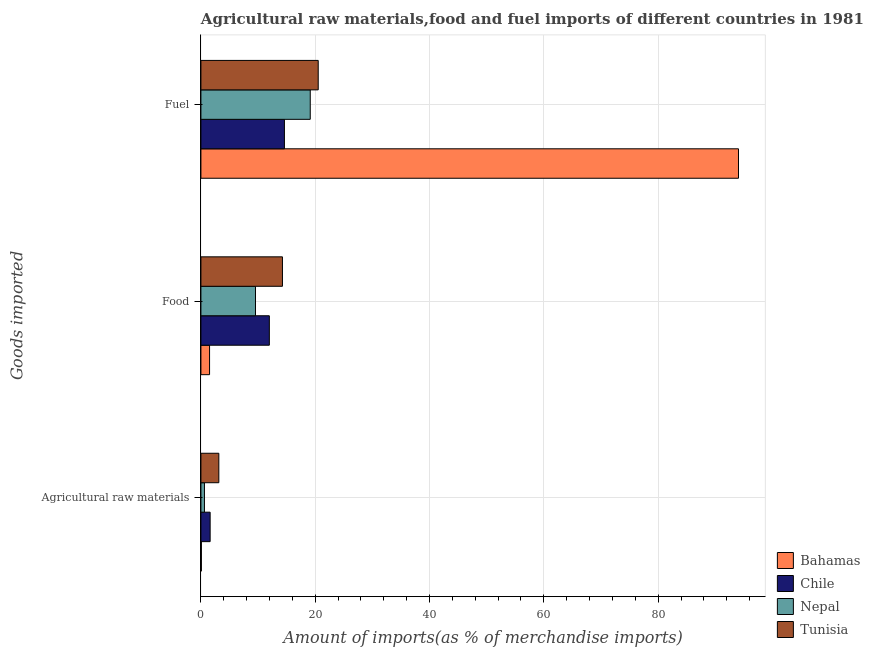How many bars are there on the 1st tick from the bottom?
Your answer should be compact. 4. What is the label of the 1st group of bars from the top?
Keep it short and to the point. Fuel. What is the percentage of fuel imports in Chile?
Your response must be concise. 14.61. Across all countries, what is the maximum percentage of food imports?
Your answer should be very brief. 14.27. Across all countries, what is the minimum percentage of fuel imports?
Ensure brevity in your answer.  14.61. In which country was the percentage of fuel imports maximum?
Make the answer very short. Bahamas. What is the total percentage of raw materials imports in the graph?
Your answer should be very brief. 5.45. What is the difference between the percentage of food imports in Tunisia and that in Nepal?
Give a very brief answer. 4.72. What is the difference between the percentage of raw materials imports in Tunisia and the percentage of fuel imports in Nepal?
Offer a very short reply. -15.99. What is the average percentage of food imports per country?
Offer a terse response. 9.33. What is the difference between the percentage of food imports and percentage of fuel imports in Chile?
Offer a terse response. -2.64. What is the ratio of the percentage of food imports in Chile to that in Bahamas?
Offer a terse response. 7.91. Is the percentage of fuel imports in Bahamas less than that in Nepal?
Offer a terse response. No. Is the difference between the percentage of raw materials imports in Tunisia and Chile greater than the difference between the percentage of fuel imports in Tunisia and Chile?
Provide a succinct answer. No. What is the difference between the highest and the second highest percentage of raw materials imports?
Ensure brevity in your answer.  1.52. What is the difference between the highest and the lowest percentage of fuel imports?
Offer a very short reply. 79.45. In how many countries, is the percentage of food imports greater than the average percentage of food imports taken over all countries?
Your answer should be very brief. 3. What does the 3rd bar from the top in Fuel represents?
Provide a succinct answer. Chile. What does the 2nd bar from the bottom in Food represents?
Keep it short and to the point. Chile. How many bars are there?
Provide a short and direct response. 12. Are all the bars in the graph horizontal?
Ensure brevity in your answer.  Yes. How many countries are there in the graph?
Give a very brief answer. 4. Are the values on the major ticks of X-axis written in scientific E-notation?
Ensure brevity in your answer.  No. Does the graph contain any zero values?
Make the answer very short. No. How many legend labels are there?
Your response must be concise. 4. What is the title of the graph?
Your answer should be compact. Agricultural raw materials,food and fuel imports of different countries in 1981. What is the label or title of the X-axis?
Offer a very short reply. Amount of imports(as % of merchandise imports). What is the label or title of the Y-axis?
Your answer should be very brief. Goods imported. What is the Amount of imports(as % of merchandise imports) of Bahamas in Agricultural raw materials?
Provide a short and direct response. 0.08. What is the Amount of imports(as % of merchandise imports) of Chile in Agricultural raw materials?
Give a very brief answer. 1.61. What is the Amount of imports(as % of merchandise imports) of Nepal in Agricultural raw materials?
Your response must be concise. 0.62. What is the Amount of imports(as % of merchandise imports) of Tunisia in Agricultural raw materials?
Offer a very short reply. 3.13. What is the Amount of imports(as % of merchandise imports) of Bahamas in Food?
Provide a short and direct response. 1.51. What is the Amount of imports(as % of merchandise imports) in Chile in Food?
Keep it short and to the point. 11.97. What is the Amount of imports(as % of merchandise imports) in Nepal in Food?
Your answer should be very brief. 9.55. What is the Amount of imports(as % of merchandise imports) in Tunisia in Food?
Ensure brevity in your answer.  14.27. What is the Amount of imports(as % of merchandise imports) of Bahamas in Fuel?
Provide a short and direct response. 94.06. What is the Amount of imports(as % of merchandise imports) in Chile in Fuel?
Offer a terse response. 14.61. What is the Amount of imports(as % of merchandise imports) of Nepal in Fuel?
Offer a very short reply. 19.13. What is the Amount of imports(as % of merchandise imports) in Tunisia in Fuel?
Give a very brief answer. 20.52. Across all Goods imported, what is the maximum Amount of imports(as % of merchandise imports) of Bahamas?
Provide a short and direct response. 94.06. Across all Goods imported, what is the maximum Amount of imports(as % of merchandise imports) in Chile?
Offer a very short reply. 14.61. Across all Goods imported, what is the maximum Amount of imports(as % of merchandise imports) of Nepal?
Make the answer very short. 19.13. Across all Goods imported, what is the maximum Amount of imports(as % of merchandise imports) in Tunisia?
Make the answer very short. 20.52. Across all Goods imported, what is the minimum Amount of imports(as % of merchandise imports) in Bahamas?
Make the answer very short. 0.08. Across all Goods imported, what is the minimum Amount of imports(as % of merchandise imports) in Chile?
Provide a short and direct response. 1.61. Across all Goods imported, what is the minimum Amount of imports(as % of merchandise imports) in Nepal?
Give a very brief answer. 0.62. Across all Goods imported, what is the minimum Amount of imports(as % of merchandise imports) of Tunisia?
Offer a terse response. 3.13. What is the total Amount of imports(as % of merchandise imports) of Bahamas in the graph?
Provide a succinct answer. 95.65. What is the total Amount of imports(as % of merchandise imports) of Chile in the graph?
Your answer should be compact. 28.2. What is the total Amount of imports(as % of merchandise imports) of Nepal in the graph?
Make the answer very short. 29.29. What is the total Amount of imports(as % of merchandise imports) in Tunisia in the graph?
Your answer should be compact. 37.93. What is the difference between the Amount of imports(as % of merchandise imports) of Bahamas in Agricultural raw materials and that in Food?
Keep it short and to the point. -1.43. What is the difference between the Amount of imports(as % of merchandise imports) in Chile in Agricultural raw materials and that in Food?
Keep it short and to the point. -10.36. What is the difference between the Amount of imports(as % of merchandise imports) in Nepal in Agricultural raw materials and that in Food?
Provide a short and direct response. -8.93. What is the difference between the Amount of imports(as % of merchandise imports) of Tunisia in Agricultural raw materials and that in Food?
Offer a terse response. -11.13. What is the difference between the Amount of imports(as % of merchandise imports) of Bahamas in Agricultural raw materials and that in Fuel?
Make the answer very short. -93.98. What is the difference between the Amount of imports(as % of merchandise imports) in Chile in Agricultural raw materials and that in Fuel?
Your response must be concise. -13. What is the difference between the Amount of imports(as % of merchandise imports) of Nepal in Agricultural raw materials and that in Fuel?
Your answer should be very brief. -18.51. What is the difference between the Amount of imports(as % of merchandise imports) of Tunisia in Agricultural raw materials and that in Fuel?
Offer a terse response. -17.39. What is the difference between the Amount of imports(as % of merchandise imports) in Bahamas in Food and that in Fuel?
Your answer should be very brief. -92.54. What is the difference between the Amount of imports(as % of merchandise imports) of Chile in Food and that in Fuel?
Your response must be concise. -2.64. What is the difference between the Amount of imports(as % of merchandise imports) of Nepal in Food and that in Fuel?
Offer a terse response. -9.58. What is the difference between the Amount of imports(as % of merchandise imports) in Tunisia in Food and that in Fuel?
Provide a short and direct response. -6.26. What is the difference between the Amount of imports(as % of merchandise imports) of Bahamas in Agricultural raw materials and the Amount of imports(as % of merchandise imports) of Chile in Food?
Provide a succinct answer. -11.89. What is the difference between the Amount of imports(as % of merchandise imports) of Bahamas in Agricultural raw materials and the Amount of imports(as % of merchandise imports) of Nepal in Food?
Keep it short and to the point. -9.47. What is the difference between the Amount of imports(as % of merchandise imports) of Bahamas in Agricultural raw materials and the Amount of imports(as % of merchandise imports) of Tunisia in Food?
Your response must be concise. -14.19. What is the difference between the Amount of imports(as % of merchandise imports) of Chile in Agricultural raw materials and the Amount of imports(as % of merchandise imports) of Nepal in Food?
Your answer should be compact. -7.93. What is the difference between the Amount of imports(as % of merchandise imports) of Chile in Agricultural raw materials and the Amount of imports(as % of merchandise imports) of Tunisia in Food?
Make the answer very short. -12.65. What is the difference between the Amount of imports(as % of merchandise imports) of Nepal in Agricultural raw materials and the Amount of imports(as % of merchandise imports) of Tunisia in Food?
Keep it short and to the point. -13.65. What is the difference between the Amount of imports(as % of merchandise imports) in Bahamas in Agricultural raw materials and the Amount of imports(as % of merchandise imports) in Chile in Fuel?
Your answer should be very brief. -14.53. What is the difference between the Amount of imports(as % of merchandise imports) of Bahamas in Agricultural raw materials and the Amount of imports(as % of merchandise imports) of Nepal in Fuel?
Give a very brief answer. -19.05. What is the difference between the Amount of imports(as % of merchandise imports) of Bahamas in Agricultural raw materials and the Amount of imports(as % of merchandise imports) of Tunisia in Fuel?
Offer a very short reply. -20.44. What is the difference between the Amount of imports(as % of merchandise imports) in Chile in Agricultural raw materials and the Amount of imports(as % of merchandise imports) in Nepal in Fuel?
Provide a short and direct response. -17.52. What is the difference between the Amount of imports(as % of merchandise imports) of Chile in Agricultural raw materials and the Amount of imports(as % of merchandise imports) of Tunisia in Fuel?
Provide a succinct answer. -18.91. What is the difference between the Amount of imports(as % of merchandise imports) in Nepal in Agricultural raw materials and the Amount of imports(as % of merchandise imports) in Tunisia in Fuel?
Make the answer very short. -19.91. What is the difference between the Amount of imports(as % of merchandise imports) in Bahamas in Food and the Amount of imports(as % of merchandise imports) in Chile in Fuel?
Offer a terse response. -13.1. What is the difference between the Amount of imports(as % of merchandise imports) in Bahamas in Food and the Amount of imports(as % of merchandise imports) in Nepal in Fuel?
Ensure brevity in your answer.  -17.62. What is the difference between the Amount of imports(as % of merchandise imports) in Bahamas in Food and the Amount of imports(as % of merchandise imports) in Tunisia in Fuel?
Your answer should be very brief. -19.01. What is the difference between the Amount of imports(as % of merchandise imports) of Chile in Food and the Amount of imports(as % of merchandise imports) of Nepal in Fuel?
Offer a terse response. -7.16. What is the difference between the Amount of imports(as % of merchandise imports) of Chile in Food and the Amount of imports(as % of merchandise imports) of Tunisia in Fuel?
Provide a short and direct response. -8.55. What is the difference between the Amount of imports(as % of merchandise imports) in Nepal in Food and the Amount of imports(as % of merchandise imports) in Tunisia in Fuel?
Make the answer very short. -10.98. What is the average Amount of imports(as % of merchandise imports) of Bahamas per Goods imported?
Provide a short and direct response. 31.88. What is the average Amount of imports(as % of merchandise imports) in Chile per Goods imported?
Make the answer very short. 9.4. What is the average Amount of imports(as % of merchandise imports) in Nepal per Goods imported?
Your answer should be compact. 9.76. What is the average Amount of imports(as % of merchandise imports) in Tunisia per Goods imported?
Provide a succinct answer. 12.64. What is the difference between the Amount of imports(as % of merchandise imports) of Bahamas and Amount of imports(as % of merchandise imports) of Chile in Agricultural raw materials?
Keep it short and to the point. -1.53. What is the difference between the Amount of imports(as % of merchandise imports) of Bahamas and Amount of imports(as % of merchandise imports) of Nepal in Agricultural raw materials?
Ensure brevity in your answer.  -0.54. What is the difference between the Amount of imports(as % of merchandise imports) of Bahamas and Amount of imports(as % of merchandise imports) of Tunisia in Agricultural raw materials?
Your answer should be compact. -3.05. What is the difference between the Amount of imports(as % of merchandise imports) of Chile and Amount of imports(as % of merchandise imports) of Nepal in Agricultural raw materials?
Provide a short and direct response. 1. What is the difference between the Amount of imports(as % of merchandise imports) of Chile and Amount of imports(as % of merchandise imports) of Tunisia in Agricultural raw materials?
Ensure brevity in your answer.  -1.52. What is the difference between the Amount of imports(as % of merchandise imports) in Nepal and Amount of imports(as % of merchandise imports) in Tunisia in Agricultural raw materials?
Give a very brief answer. -2.52. What is the difference between the Amount of imports(as % of merchandise imports) in Bahamas and Amount of imports(as % of merchandise imports) in Chile in Food?
Your answer should be compact. -10.46. What is the difference between the Amount of imports(as % of merchandise imports) of Bahamas and Amount of imports(as % of merchandise imports) of Nepal in Food?
Offer a terse response. -8.03. What is the difference between the Amount of imports(as % of merchandise imports) of Bahamas and Amount of imports(as % of merchandise imports) of Tunisia in Food?
Offer a very short reply. -12.75. What is the difference between the Amount of imports(as % of merchandise imports) of Chile and Amount of imports(as % of merchandise imports) of Nepal in Food?
Your answer should be compact. 2.43. What is the difference between the Amount of imports(as % of merchandise imports) in Chile and Amount of imports(as % of merchandise imports) in Tunisia in Food?
Your response must be concise. -2.29. What is the difference between the Amount of imports(as % of merchandise imports) in Nepal and Amount of imports(as % of merchandise imports) in Tunisia in Food?
Ensure brevity in your answer.  -4.72. What is the difference between the Amount of imports(as % of merchandise imports) in Bahamas and Amount of imports(as % of merchandise imports) in Chile in Fuel?
Give a very brief answer. 79.45. What is the difference between the Amount of imports(as % of merchandise imports) in Bahamas and Amount of imports(as % of merchandise imports) in Nepal in Fuel?
Make the answer very short. 74.93. What is the difference between the Amount of imports(as % of merchandise imports) of Bahamas and Amount of imports(as % of merchandise imports) of Tunisia in Fuel?
Provide a short and direct response. 73.53. What is the difference between the Amount of imports(as % of merchandise imports) of Chile and Amount of imports(as % of merchandise imports) of Nepal in Fuel?
Give a very brief answer. -4.52. What is the difference between the Amount of imports(as % of merchandise imports) of Chile and Amount of imports(as % of merchandise imports) of Tunisia in Fuel?
Ensure brevity in your answer.  -5.91. What is the difference between the Amount of imports(as % of merchandise imports) of Nepal and Amount of imports(as % of merchandise imports) of Tunisia in Fuel?
Ensure brevity in your answer.  -1.39. What is the ratio of the Amount of imports(as % of merchandise imports) in Bahamas in Agricultural raw materials to that in Food?
Your response must be concise. 0.05. What is the ratio of the Amount of imports(as % of merchandise imports) in Chile in Agricultural raw materials to that in Food?
Offer a terse response. 0.13. What is the ratio of the Amount of imports(as % of merchandise imports) in Nepal in Agricultural raw materials to that in Food?
Keep it short and to the point. 0.06. What is the ratio of the Amount of imports(as % of merchandise imports) of Tunisia in Agricultural raw materials to that in Food?
Keep it short and to the point. 0.22. What is the ratio of the Amount of imports(as % of merchandise imports) in Bahamas in Agricultural raw materials to that in Fuel?
Keep it short and to the point. 0. What is the ratio of the Amount of imports(as % of merchandise imports) of Chile in Agricultural raw materials to that in Fuel?
Your response must be concise. 0.11. What is the ratio of the Amount of imports(as % of merchandise imports) in Nepal in Agricultural raw materials to that in Fuel?
Your answer should be very brief. 0.03. What is the ratio of the Amount of imports(as % of merchandise imports) in Tunisia in Agricultural raw materials to that in Fuel?
Make the answer very short. 0.15. What is the ratio of the Amount of imports(as % of merchandise imports) in Bahamas in Food to that in Fuel?
Offer a terse response. 0.02. What is the ratio of the Amount of imports(as % of merchandise imports) in Chile in Food to that in Fuel?
Offer a very short reply. 0.82. What is the ratio of the Amount of imports(as % of merchandise imports) of Nepal in Food to that in Fuel?
Make the answer very short. 0.5. What is the ratio of the Amount of imports(as % of merchandise imports) in Tunisia in Food to that in Fuel?
Provide a short and direct response. 0.7. What is the difference between the highest and the second highest Amount of imports(as % of merchandise imports) of Bahamas?
Your answer should be compact. 92.54. What is the difference between the highest and the second highest Amount of imports(as % of merchandise imports) in Chile?
Provide a short and direct response. 2.64. What is the difference between the highest and the second highest Amount of imports(as % of merchandise imports) in Nepal?
Your answer should be compact. 9.58. What is the difference between the highest and the second highest Amount of imports(as % of merchandise imports) in Tunisia?
Provide a succinct answer. 6.26. What is the difference between the highest and the lowest Amount of imports(as % of merchandise imports) of Bahamas?
Provide a short and direct response. 93.98. What is the difference between the highest and the lowest Amount of imports(as % of merchandise imports) in Chile?
Give a very brief answer. 13. What is the difference between the highest and the lowest Amount of imports(as % of merchandise imports) in Nepal?
Provide a short and direct response. 18.51. What is the difference between the highest and the lowest Amount of imports(as % of merchandise imports) in Tunisia?
Ensure brevity in your answer.  17.39. 